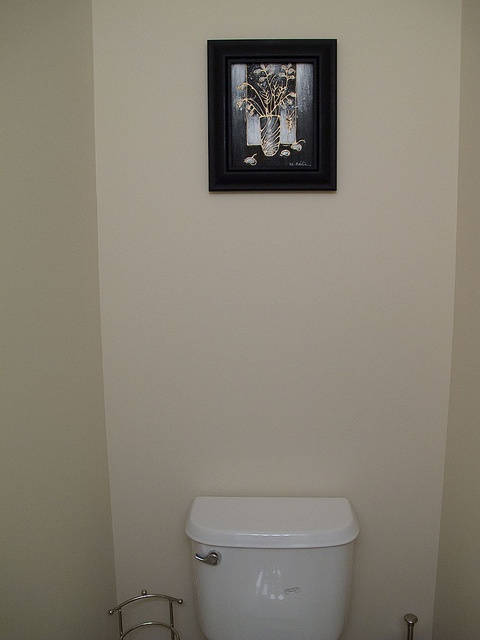Describe the objects in this image and their specific colors. I can see a toilet in gray tones in this image. 